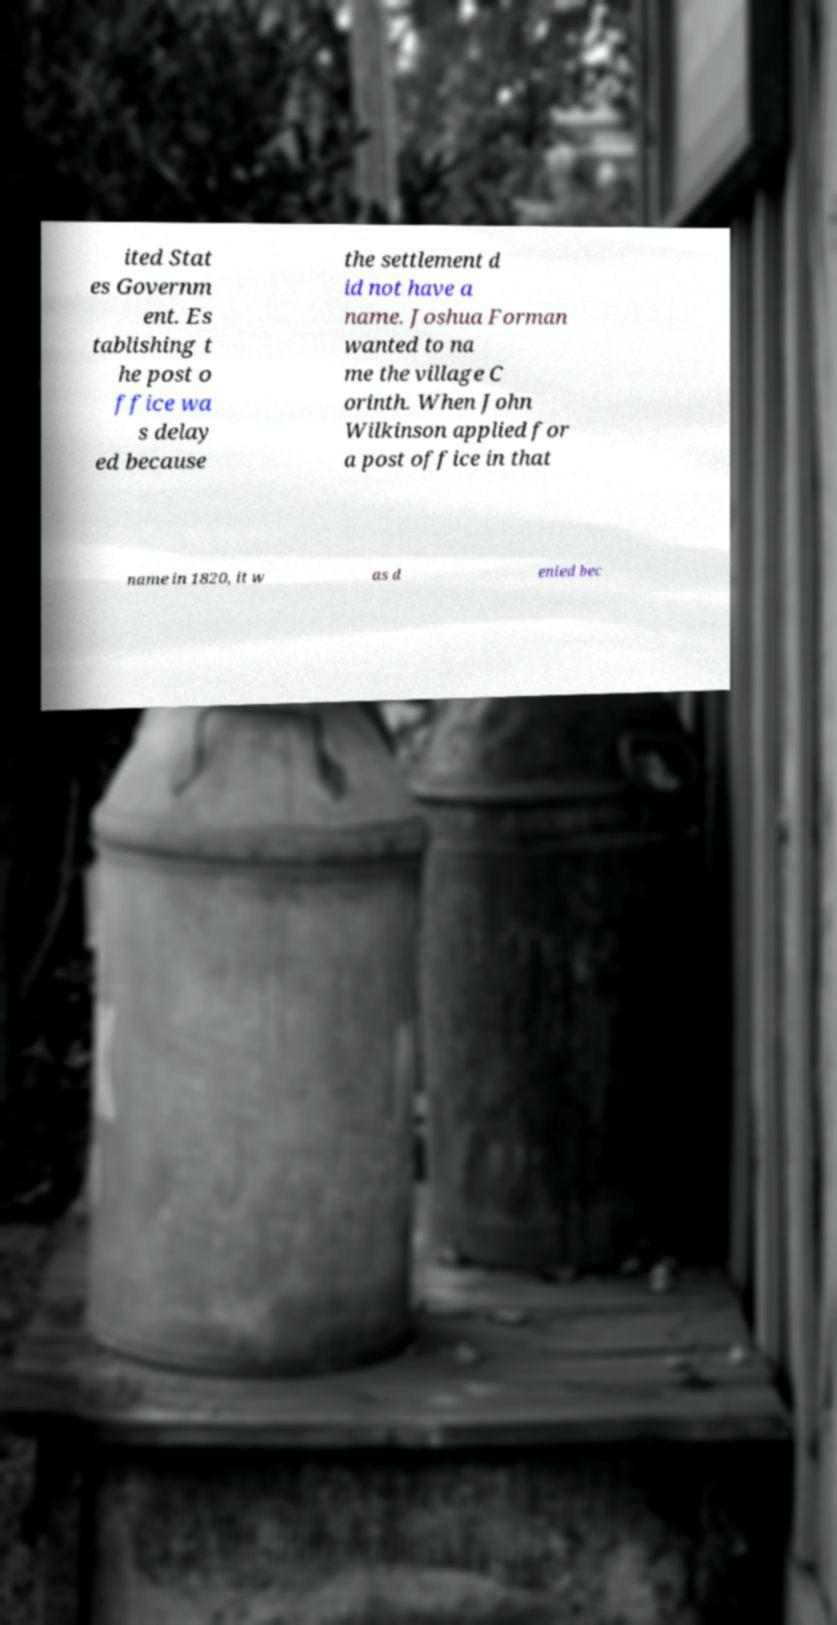There's text embedded in this image that I need extracted. Can you transcribe it verbatim? ited Stat es Governm ent. Es tablishing t he post o ffice wa s delay ed because the settlement d id not have a name. Joshua Forman wanted to na me the village C orinth. When John Wilkinson applied for a post office in that name in 1820, it w as d enied bec 